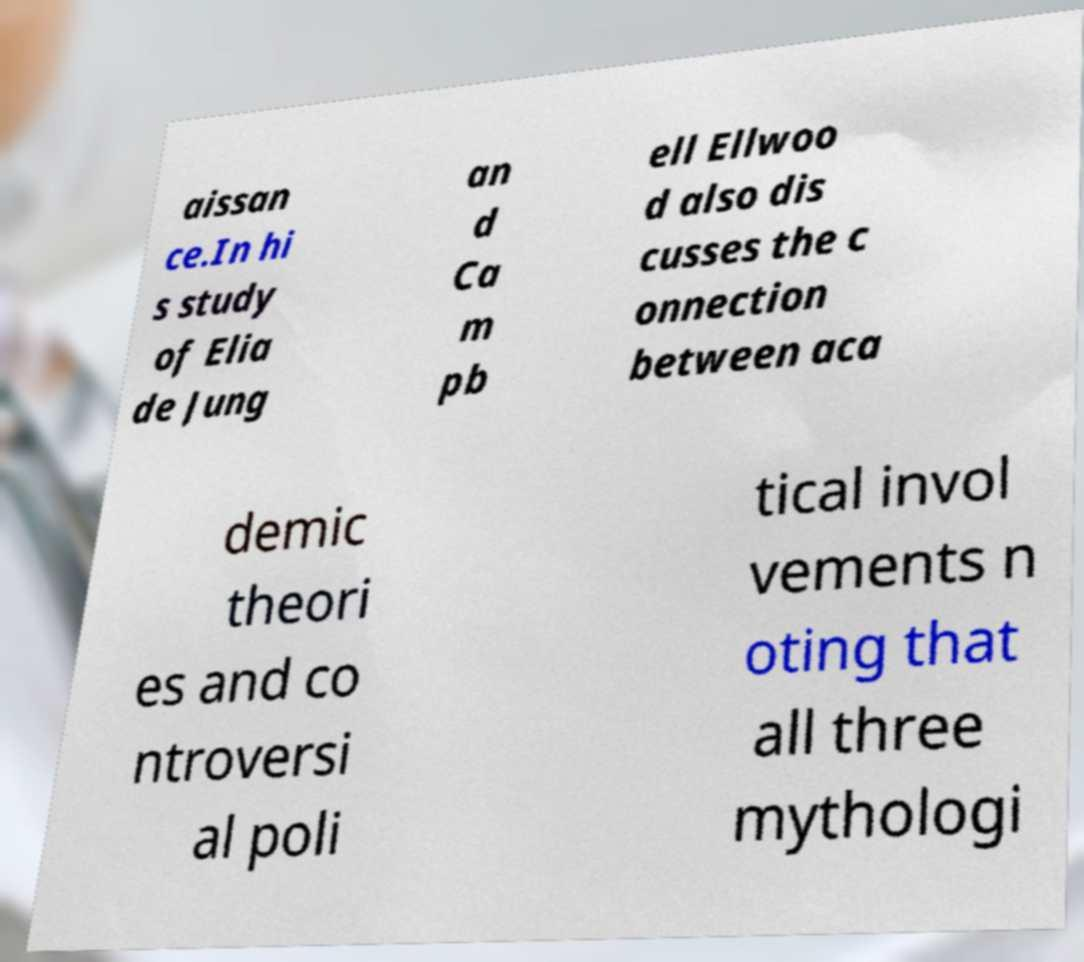What messages or text are displayed in this image? I need them in a readable, typed format. aissan ce.In hi s study of Elia de Jung an d Ca m pb ell Ellwoo d also dis cusses the c onnection between aca demic theori es and co ntroversi al poli tical invol vements n oting that all three mythologi 